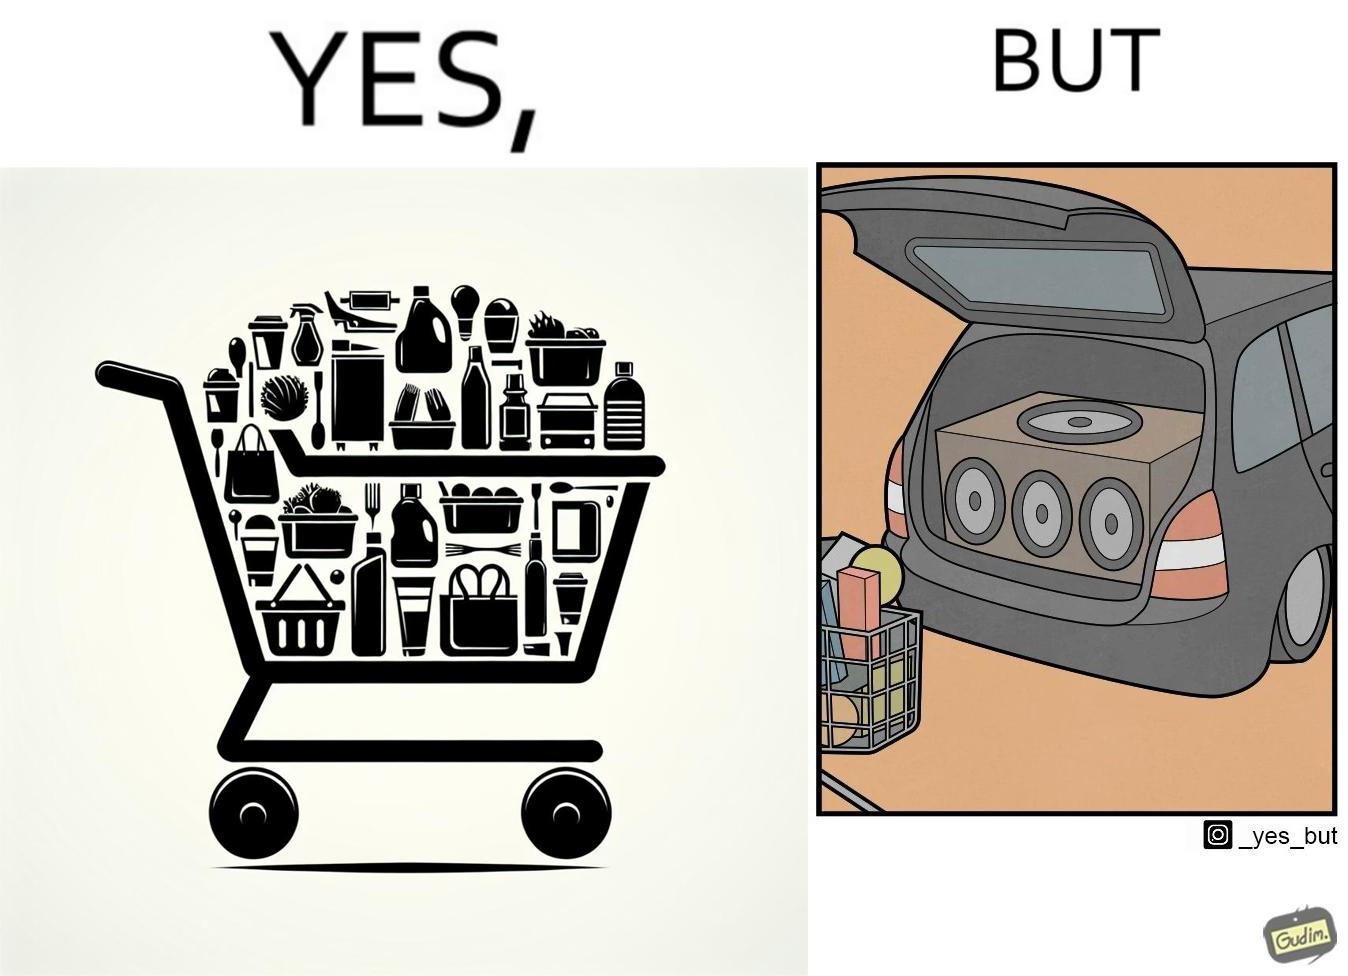Provide a description of this image. The image is ironic, because a car trunk was earlier designed to keep some extra luggage or things but people nowadays get speakers installed in the trunk which in turn reduces the space in the trunk and making it difficult for people to store the extra luggage in the trunk 